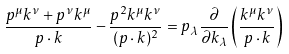Convert formula to latex. <formula><loc_0><loc_0><loc_500><loc_500>\frac { p ^ { \mu } k ^ { \nu } + p ^ { \nu } k ^ { \mu } } { p \cdot k } - \frac { p ^ { 2 } k ^ { \mu } k ^ { \nu } } { ( p \cdot k ) ^ { 2 } } = p _ { \lambda } \frac { \partial } { \partial k _ { \lambda } } \left ( \frac { k ^ { \mu } k ^ { \nu } } { p \cdot k } \right )</formula> 